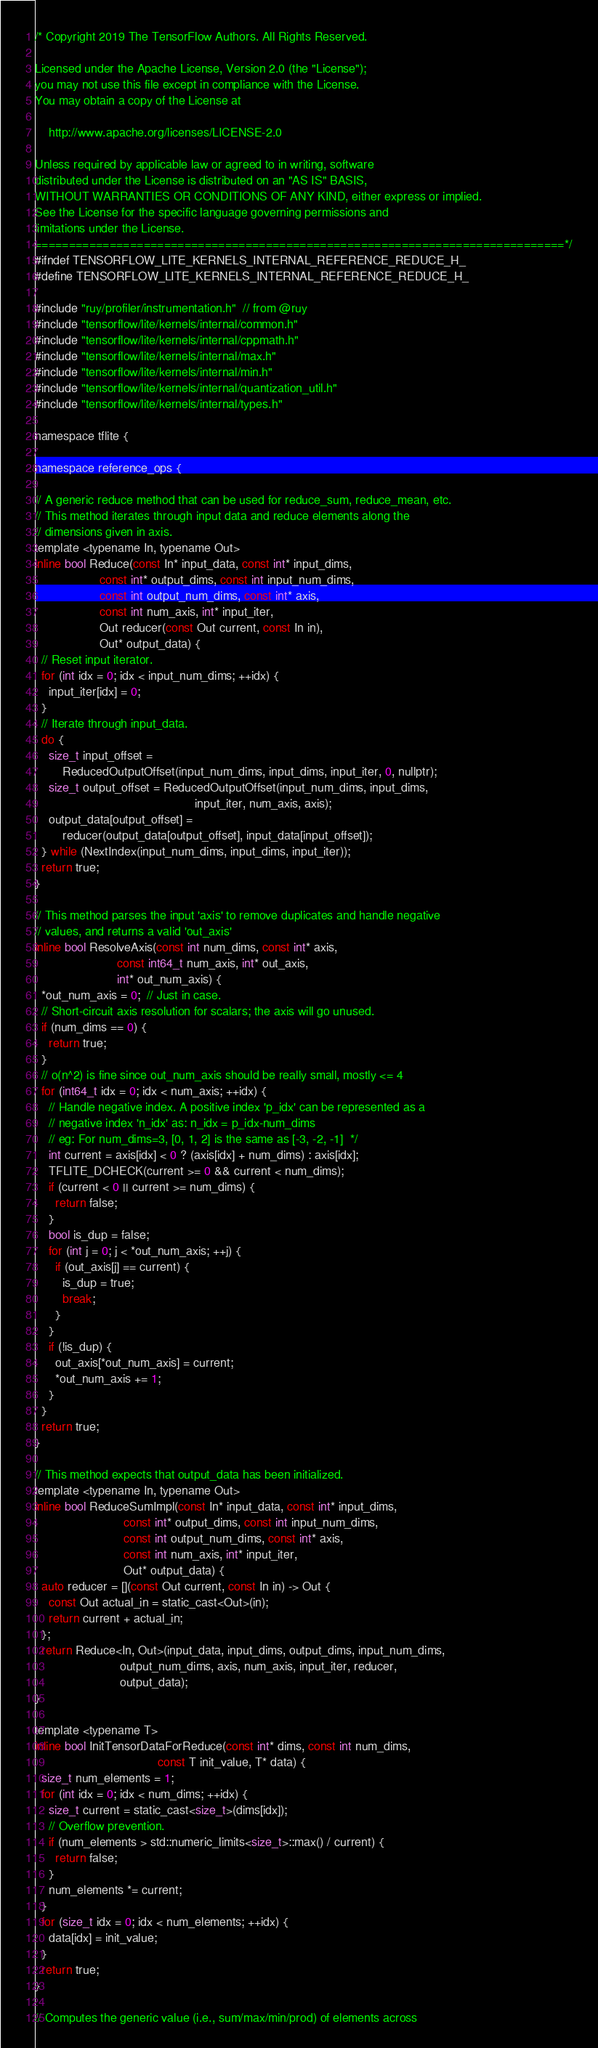<code> <loc_0><loc_0><loc_500><loc_500><_C_>/* Copyright 2019 The TensorFlow Authors. All Rights Reserved.

Licensed under the Apache License, Version 2.0 (the "License");
you may not use this file except in compliance with the License.
You may obtain a copy of the License at

    http://www.apache.org/licenses/LICENSE-2.0

Unless required by applicable law or agreed to in writing, software
distributed under the License is distributed on an "AS IS" BASIS,
WITHOUT WARRANTIES OR CONDITIONS OF ANY KIND, either express or implied.
See the License for the specific language governing permissions and
limitations under the License.
==============================================================================*/
#ifndef TENSORFLOW_LITE_KERNELS_INTERNAL_REFERENCE_REDUCE_H_
#define TENSORFLOW_LITE_KERNELS_INTERNAL_REFERENCE_REDUCE_H_

#include "ruy/profiler/instrumentation.h"  // from @ruy
#include "tensorflow/lite/kernels/internal/common.h"
#include "tensorflow/lite/kernels/internal/cppmath.h"
#include "tensorflow/lite/kernels/internal/max.h"
#include "tensorflow/lite/kernels/internal/min.h"
#include "tensorflow/lite/kernels/internal/quantization_util.h"
#include "tensorflow/lite/kernels/internal/types.h"

namespace tflite {

namespace reference_ops {

// A generic reduce method that can be used for reduce_sum, reduce_mean, etc.
// This method iterates through input data and reduce elements along the
// dimensions given in axis.
template <typename In, typename Out>
inline bool Reduce(const In* input_data, const int* input_dims,
                   const int* output_dims, const int input_num_dims,
                   const int output_num_dims, const int* axis,
                   const int num_axis, int* input_iter,
                   Out reducer(const Out current, const In in),
                   Out* output_data) {
  // Reset input iterator.
  for (int idx = 0; idx < input_num_dims; ++idx) {
    input_iter[idx] = 0;
  }
  // Iterate through input_data.
  do {
    size_t input_offset =
        ReducedOutputOffset(input_num_dims, input_dims, input_iter, 0, nullptr);
    size_t output_offset = ReducedOutputOffset(input_num_dims, input_dims,
                                               input_iter, num_axis, axis);
    output_data[output_offset] =
        reducer(output_data[output_offset], input_data[input_offset]);
  } while (NextIndex(input_num_dims, input_dims, input_iter));
  return true;
}

// This method parses the input 'axis' to remove duplicates and handle negative
// values, and returns a valid 'out_axis'
inline bool ResolveAxis(const int num_dims, const int* axis,
                        const int64_t num_axis, int* out_axis,
                        int* out_num_axis) {
  *out_num_axis = 0;  // Just in case.
  // Short-circuit axis resolution for scalars; the axis will go unused.
  if (num_dims == 0) {
    return true;
  }
  // o(n^2) is fine since out_num_axis should be really small, mostly <= 4
  for (int64_t idx = 0; idx < num_axis; ++idx) {
    // Handle negative index. A positive index 'p_idx' can be represented as a
    // negative index 'n_idx' as: n_idx = p_idx-num_dims
    // eg: For num_dims=3, [0, 1, 2] is the same as [-3, -2, -1]  */
    int current = axis[idx] < 0 ? (axis[idx] + num_dims) : axis[idx];
    TFLITE_DCHECK(current >= 0 && current < num_dims);
    if (current < 0 || current >= num_dims) {
      return false;
    }
    bool is_dup = false;
    for (int j = 0; j < *out_num_axis; ++j) {
      if (out_axis[j] == current) {
        is_dup = true;
        break;
      }
    }
    if (!is_dup) {
      out_axis[*out_num_axis] = current;
      *out_num_axis += 1;
    }
  }
  return true;
}

// This method expects that output_data has been initialized.
template <typename In, typename Out>
inline bool ReduceSumImpl(const In* input_data, const int* input_dims,
                          const int* output_dims, const int input_num_dims,
                          const int output_num_dims, const int* axis,
                          const int num_axis, int* input_iter,
                          Out* output_data) {
  auto reducer = [](const Out current, const In in) -> Out {
    const Out actual_in = static_cast<Out>(in);
    return current + actual_in;
  };
  return Reduce<In, Out>(input_data, input_dims, output_dims, input_num_dims,
                         output_num_dims, axis, num_axis, input_iter, reducer,
                         output_data);
}

template <typename T>
inline bool InitTensorDataForReduce(const int* dims, const int num_dims,
                                    const T init_value, T* data) {
  size_t num_elements = 1;
  for (int idx = 0; idx < num_dims; ++idx) {
    size_t current = static_cast<size_t>(dims[idx]);
    // Overflow prevention.
    if (num_elements > std::numeric_limits<size_t>::max() / current) {
      return false;
    }
    num_elements *= current;
  }
  for (size_t idx = 0; idx < num_elements; ++idx) {
    data[idx] = init_value;
  }
  return true;
}

// Computes the generic value (i.e., sum/max/min/prod) of elements across</code> 